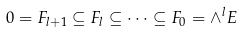<formula> <loc_0><loc_0><loc_500><loc_500>0 & = F _ { l + 1 } \subseteq F _ { l } \subseteq \cdots \subseteq F _ { 0 } = \wedge ^ { l } E</formula> 